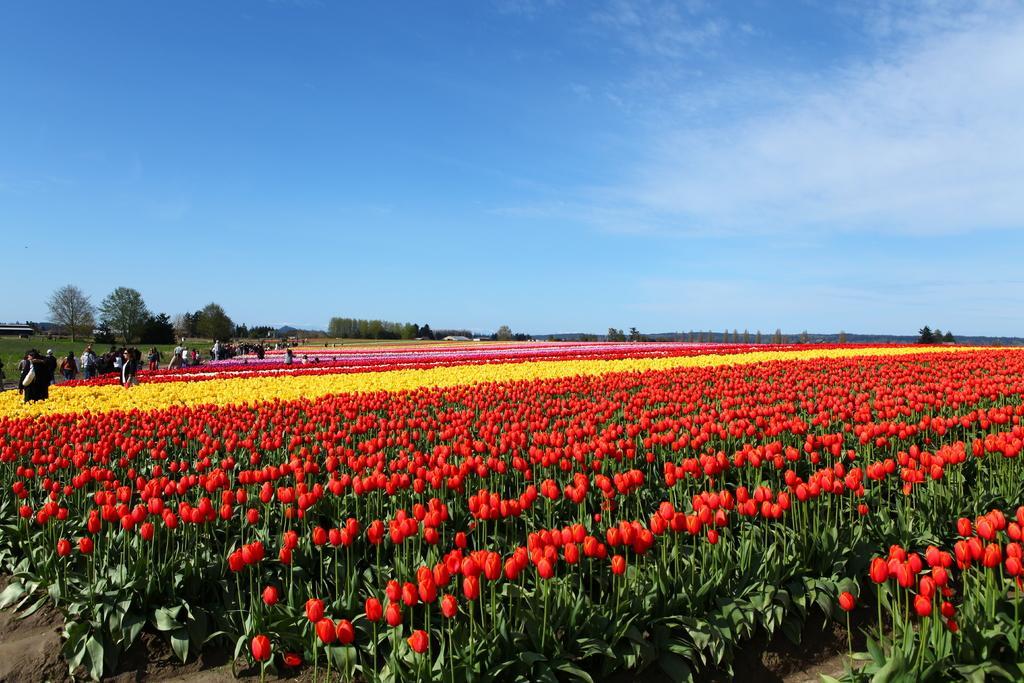Describe this image in one or two sentences. In this image there are few plants having different colors of flowers. Left side there are few persons standing. Background there are few trees on the grassland. Top of the image there is sky. 